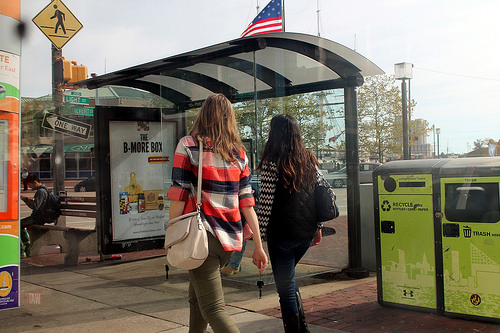<image>
Is the striped girl to the left of the dark girl? Yes. From this viewpoint, the striped girl is positioned to the left side relative to the dark girl. Is the flag above the woman? Yes. The flag is positioned above the woman in the vertical space, higher up in the scene. 